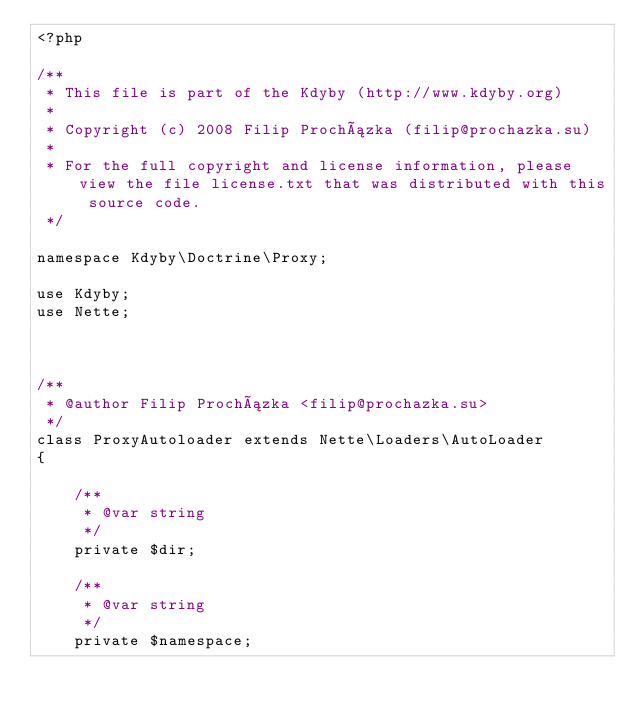Convert code to text. <code><loc_0><loc_0><loc_500><loc_500><_PHP_><?php

/**
 * This file is part of the Kdyby (http://www.kdyby.org)
 *
 * Copyright (c) 2008 Filip Procházka (filip@prochazka.su)
 *
 * For the full copyright and license information, please view the file license.txt that was distributed with this source code.
 */

namespace Kdyby\Doctrine\Proxy;

use Kdyby;
use Nette;



/**
 * @author Filip Procházka <filip@prochazka.su>
 */
class ProxyAutoloader extends Nette\Loaders\AutoLoader
{

	/**
	 * @var string
	 */
	private $dir;

	/**
	 * @var string
	 */
	private $namespace;


</code> 